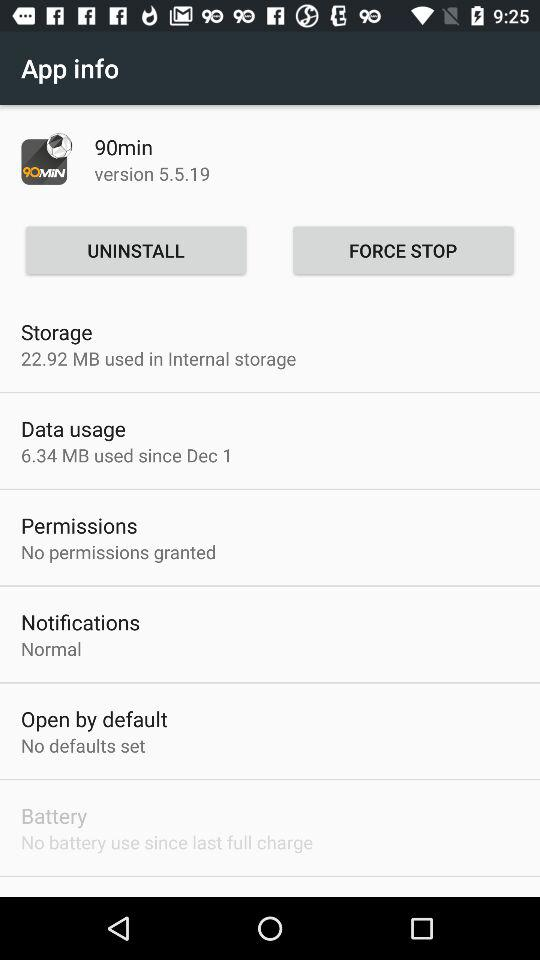How much data has this app used since December 1st?
Answer the question using a single word or phrase. 6.34 MB 